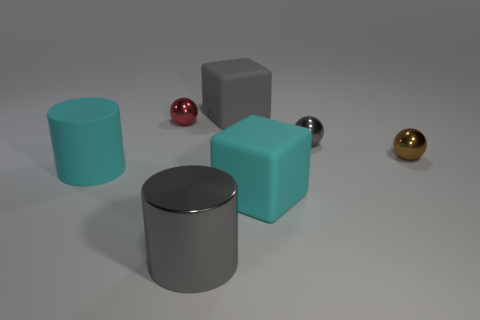Add 1 big gray metal things. How many objects exist? 8 Add 5 red balls. How many red balls exist? 6 Subtract 0 red cylinders. How many objects are left? 7 Subtract all cylinders. How many objects are left? 5 Subtract all green rubber cylinders. Subtract all big gray cylinders. How many objects are left? 6 Add 1 spheres. How many spheres are left? 4 